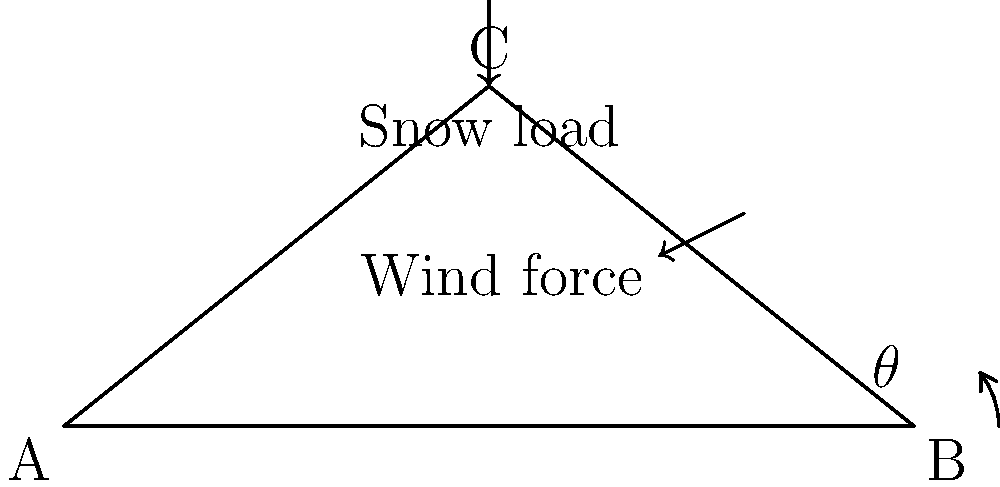As a high school teacher implementing innovative educational methods, you want to demonstrate the practical application of trigonometry in civil engineering. Consider a roof truss with a span of 10 meters and a height of 4 meters at its peak. Given that the snow load is 2 kN/m² and the wind force is 1 kN/m² acting perpendicular to the roof surface, determine the optimal angle $\theta$ for the roof truss that minimizes the total force on the structure. To solve this problem, we'll follow these steps:

1) First, we need to find the angle $\theta$ of the roof truss:
   $\tan(\theta) = \frac{\text{height}}{\frac{1}{2}\text{span}} = \frac{4}{\frac{1}{2}(10)} = \frac{4}{5} = 0.8$
   $\theta = \arctan(0.8) \approx 38.7°$

2) The total force on the roof is the vector sum of the snow load and wind force components perpendicular to the roof surface.

3) For the snow load:
   - Vertical component: $F_v = 2 \text{ kN/m²} \cdot \cos(38.7°) = 1.57 \text{ kN/m²}$

4) For the wind force:
   - Component perpendicular to the roof: $F_w = 1 \text{ kN/m²}$

5) Total force perpendicular to the roof surface:
   $F_{\text{total}} = F_v + F_w = 1.57 + 1 = 2.57 \text{ kN/m²}$

6) To find the optimal angle, we would need to minimize this total force by varying the angle $\theta$. This would involve taking the derivative of the force equation with respect to $\theta$ and setting it to zero.

7) The general equation for the total force would be:
   $F_{\text{total}}(\theta) = 2\cos(\theta) + 1$

8) Taking the derivative and setting it to zero:
   $\frac{d}{d\theta}F_{\text{total}}(\theta) = -2\sin(\theta) = 0$

9) Solving this equation:
   $-2\sin(\theta) = 0$
   $\sin(\theta) = 0$
   $\theta = 0° \text{ or } 180°$

10) The second derivative test shows that $\theta = 0°$ minimizes the function.

Therefore, theoretically, a flat roof ($\theta = 0°$) would minimize the total force. However, this is not practical for snow load and water drainage. In practice, the optimal angle is a compromise between minimizing forces and ensuring proper drainage, usually between 15° and 45°.
Answer: Theoretically 0°, practically 15°-45° 